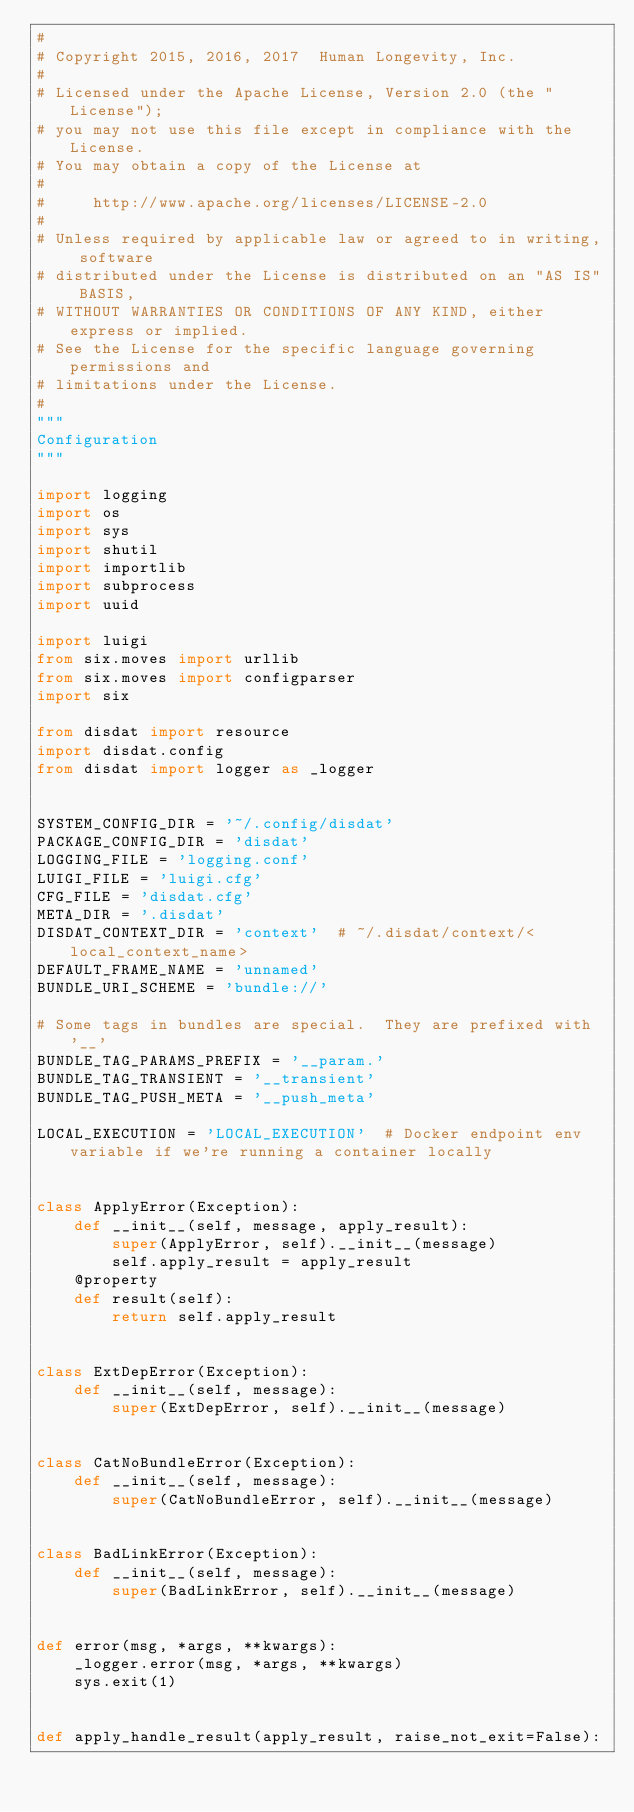<code> <loc_0><loc_0><loc_500><loc_500><_Python_>#
# Copyright 2015, 2016, 2017  Human Longevity, Inc.
#
# Licensed under the Apache License, Version 2.0 (the "License");
# you may not use this file except in compliance with the License.
# You may obtain a copy of the License at
#
#     http://www.apache.org/licenses/LICENSE-2.0
#
# Unless required by applicable law or agreed to in writing, software
# distributed under the License is distributed on an "AS IS" BASIS,
# WITHOUT WARRANTIES OR CONDITIONS OF ANY KIND, either express or implied.
# See the License for the specific language governing permissions and
# limitations under the License.
#
"""
Configuration
"""

import logging
import os
import sys
import shutil
import importlib
import subprocess
import uuid

import luigi
from six.moves import urllib
from six.moves import configparser
import six

from disdat import resource
import disdat.config
from disdat import logger as _logger


SYSTEM_CONFIG_DIR = '~/.config/disdat'
PACKAGE_CONFIG_DIR = 'disdat'
LOGGING_FILE = 'logging.conf'
LUIGI_FILE = 'luigi.cfg'
CFG_FILE = 'disdat.cfg'
META_DIR = '.disdat'
DISDAT_CONTEXT_DIR = 'context'  # ~/.disdat/context/<local_context_name>
DEFAULT_FRAME_NAME = 'unnamed'
BUNDLE_URI_SCHEME = 'bundle://'

# Some tags in bundles are special.  They are prefixed with '__'
BUNDLE_TAG_PARAMS_PREFIX = '__param.'
BUNDLE_TAG_TRANSIENT = '__transient'
BUNDLE_TAG_PUSH_META = '__push_meta'

LOCAL_EXECUTION = 'LOCAL_EXECUTION'  # Docker endpoint env variable if we're running a container locally


class ApplyError(Exception):
    def __init__(self, message, apply_result):
        super(ApplyError, self).__init__(message)
        self.apply_result = apply_result
    @property
    def result(self):
        return self.apply_result


class ExtDepError(Exception):
    def __init__(self, message):
        super(ExtDepError, self).__init__(message)


class CatNoBundleError(Exception):
    def __init__(self, message):
        super(CatNoBundleError, self).__init__(message)


class BadLinkError(Exception):
    def __init__(self, message):
        super(BadLinkError, self).__init__(message)


def error(msg, *args, **kwargs):
    _logger.error(msg, *args, **kwargs)
    sys.exit(1)


def apply_handle_result(apply_result, raise_not_exit=False):</code> 